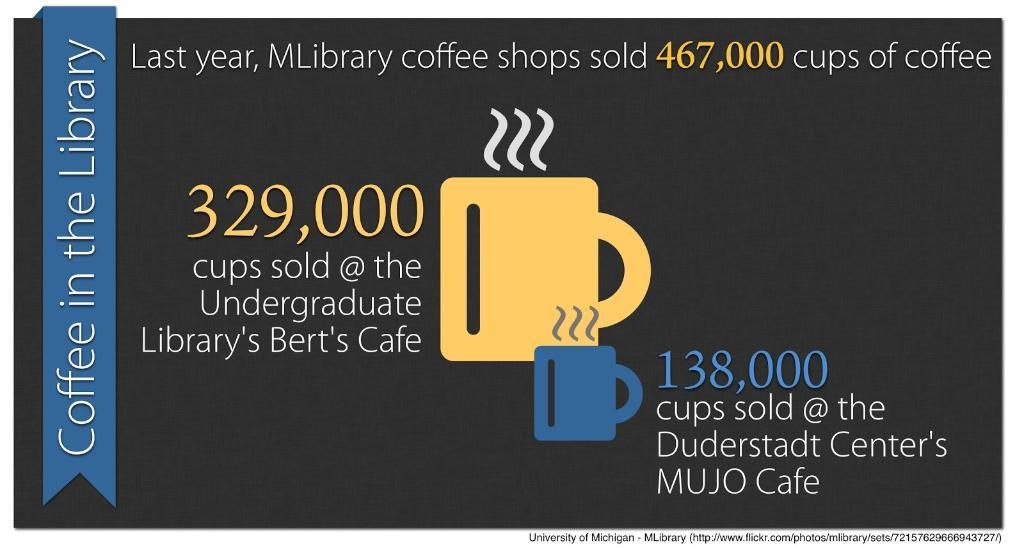<image>
Write a terse but informative summary of the picture. A flyer advertising Coffee in the Libary and a yellow mug drawn. 